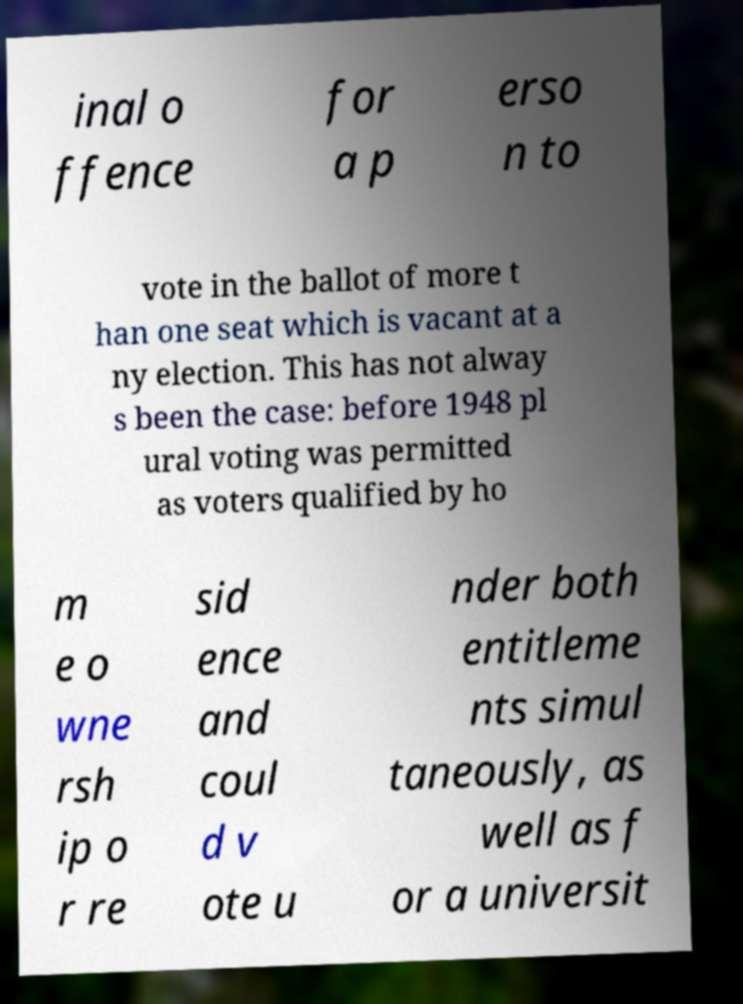What messages or text are displayed in this image? I need them in a readable, typed format. inal o ffence for a p erso n to vote in the ballot of more t han one seat which is vacant at a ny election. This has not alway s been the case: before 1948 pl ural voting was permitted as voters qualified by ho m e o wne rsh ip o r re sid ence and coul d v ote u nder both entitleme nts simul taneously, as well as f or a universit 